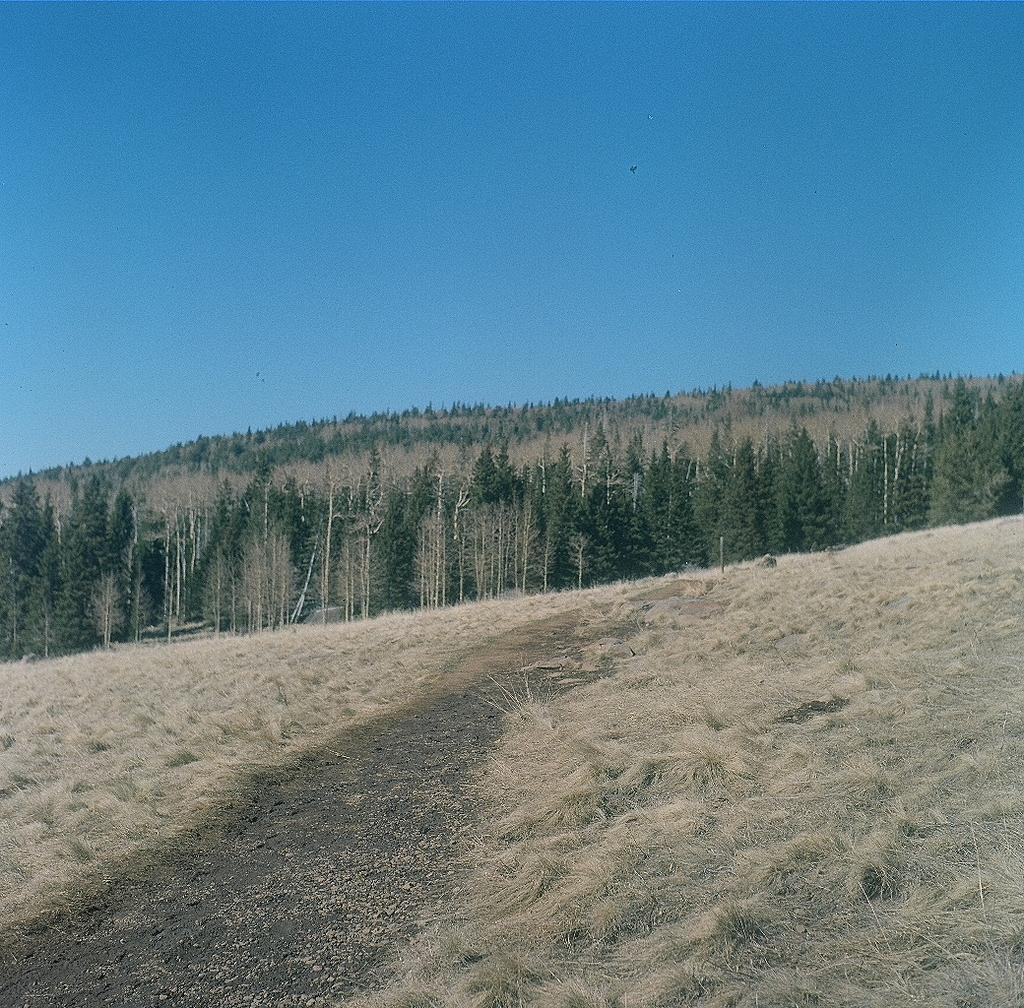What type of terrain is at the bottom of the image? There is a grassy land at the bottom of the image. What can be seen in the background of the image? There are trees in the background of the image. What color is the sky in the image? The sky is blue and visible at the top of the image. What type of soda is being advertised on the grassy land in the image? There is no soda or advertisement present in the image; it features a grassy land, trees, and a blue sky. 